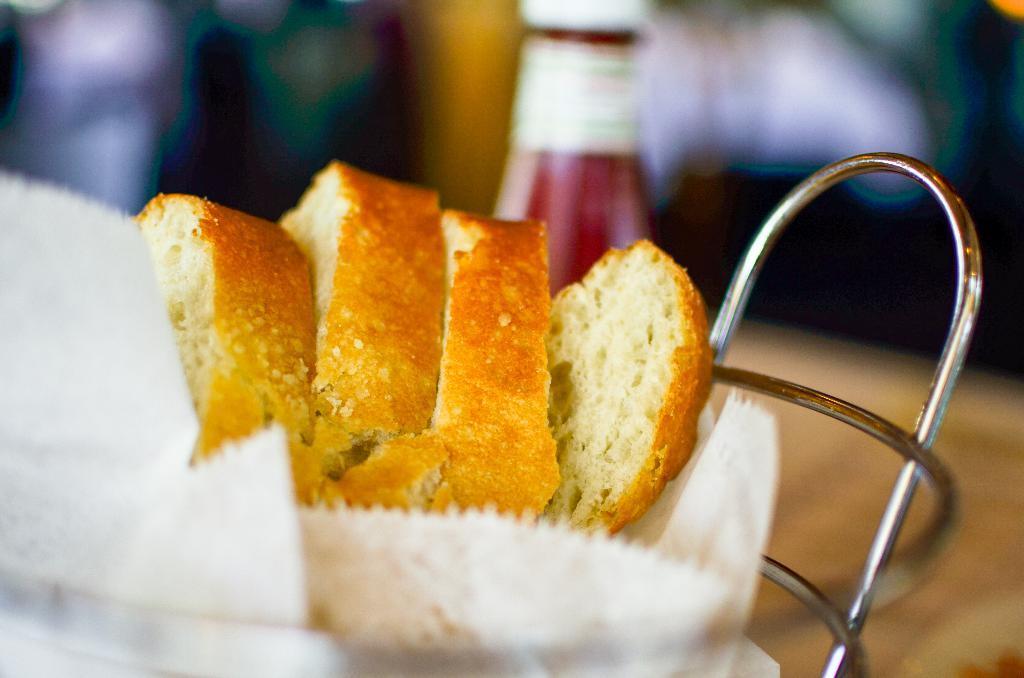Could you give a brief overview of what you see in this image? In this picture we can see food on an object. Behind the food, there is a bottle and a blurred background. 